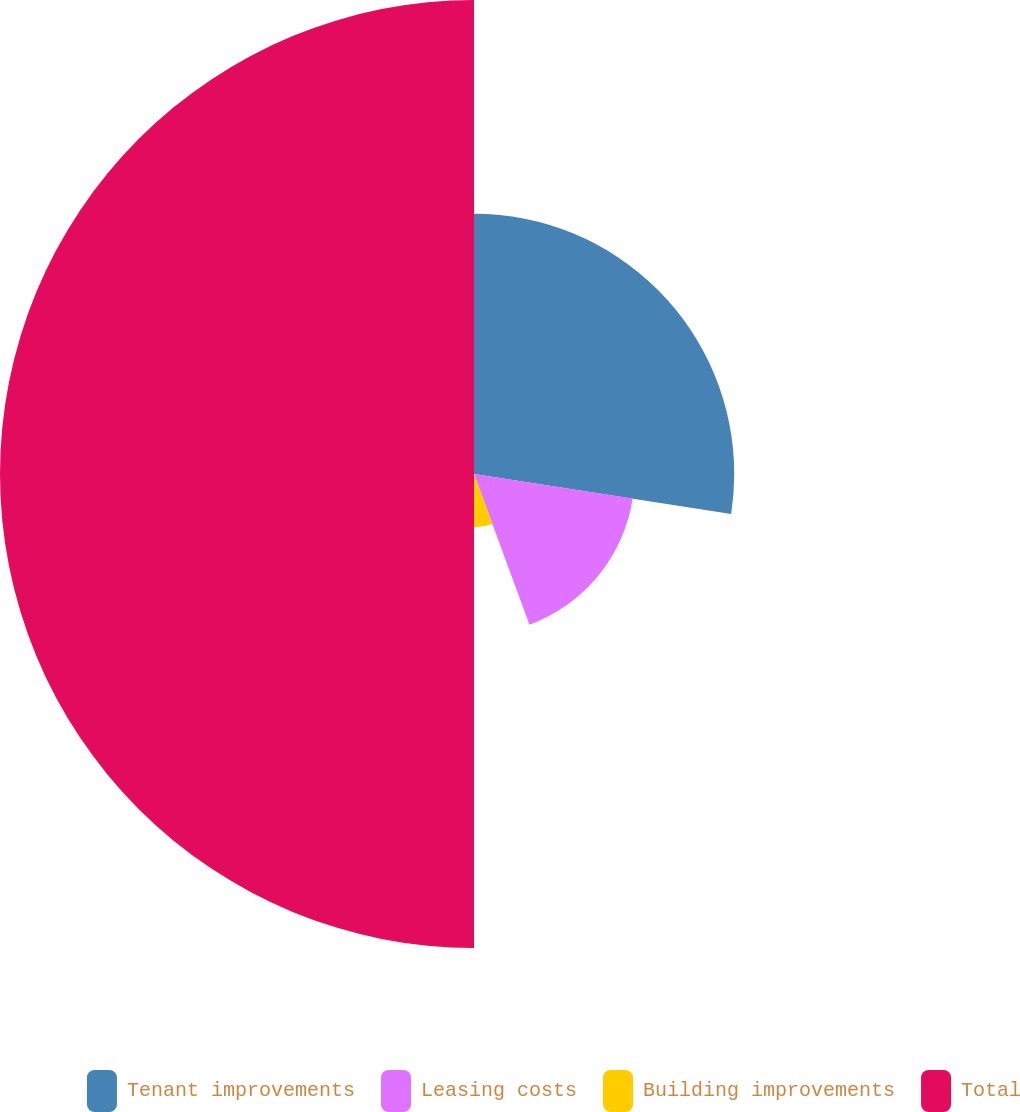<chart> <loc_0><loc_0><loc_500><loc_500><pie_chart><fcel>Tenant improvements<fcel>Leasing costs<fcel>Building improvements<fcel>Total<nl><fcel>27.45%<fcel>16.94%<fcel>5.61%<fcel>50.0%<nl></chart> 